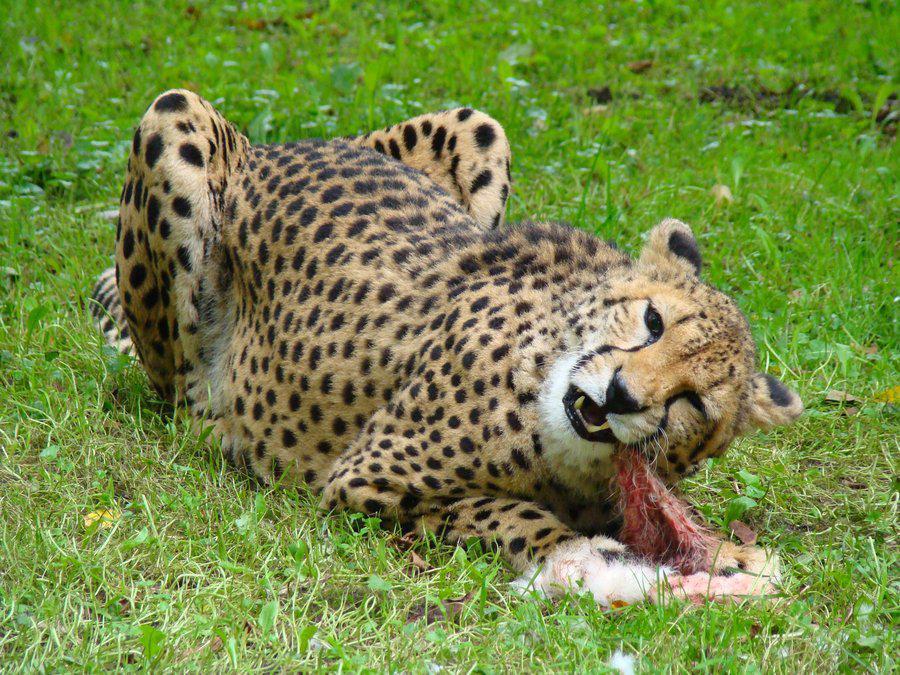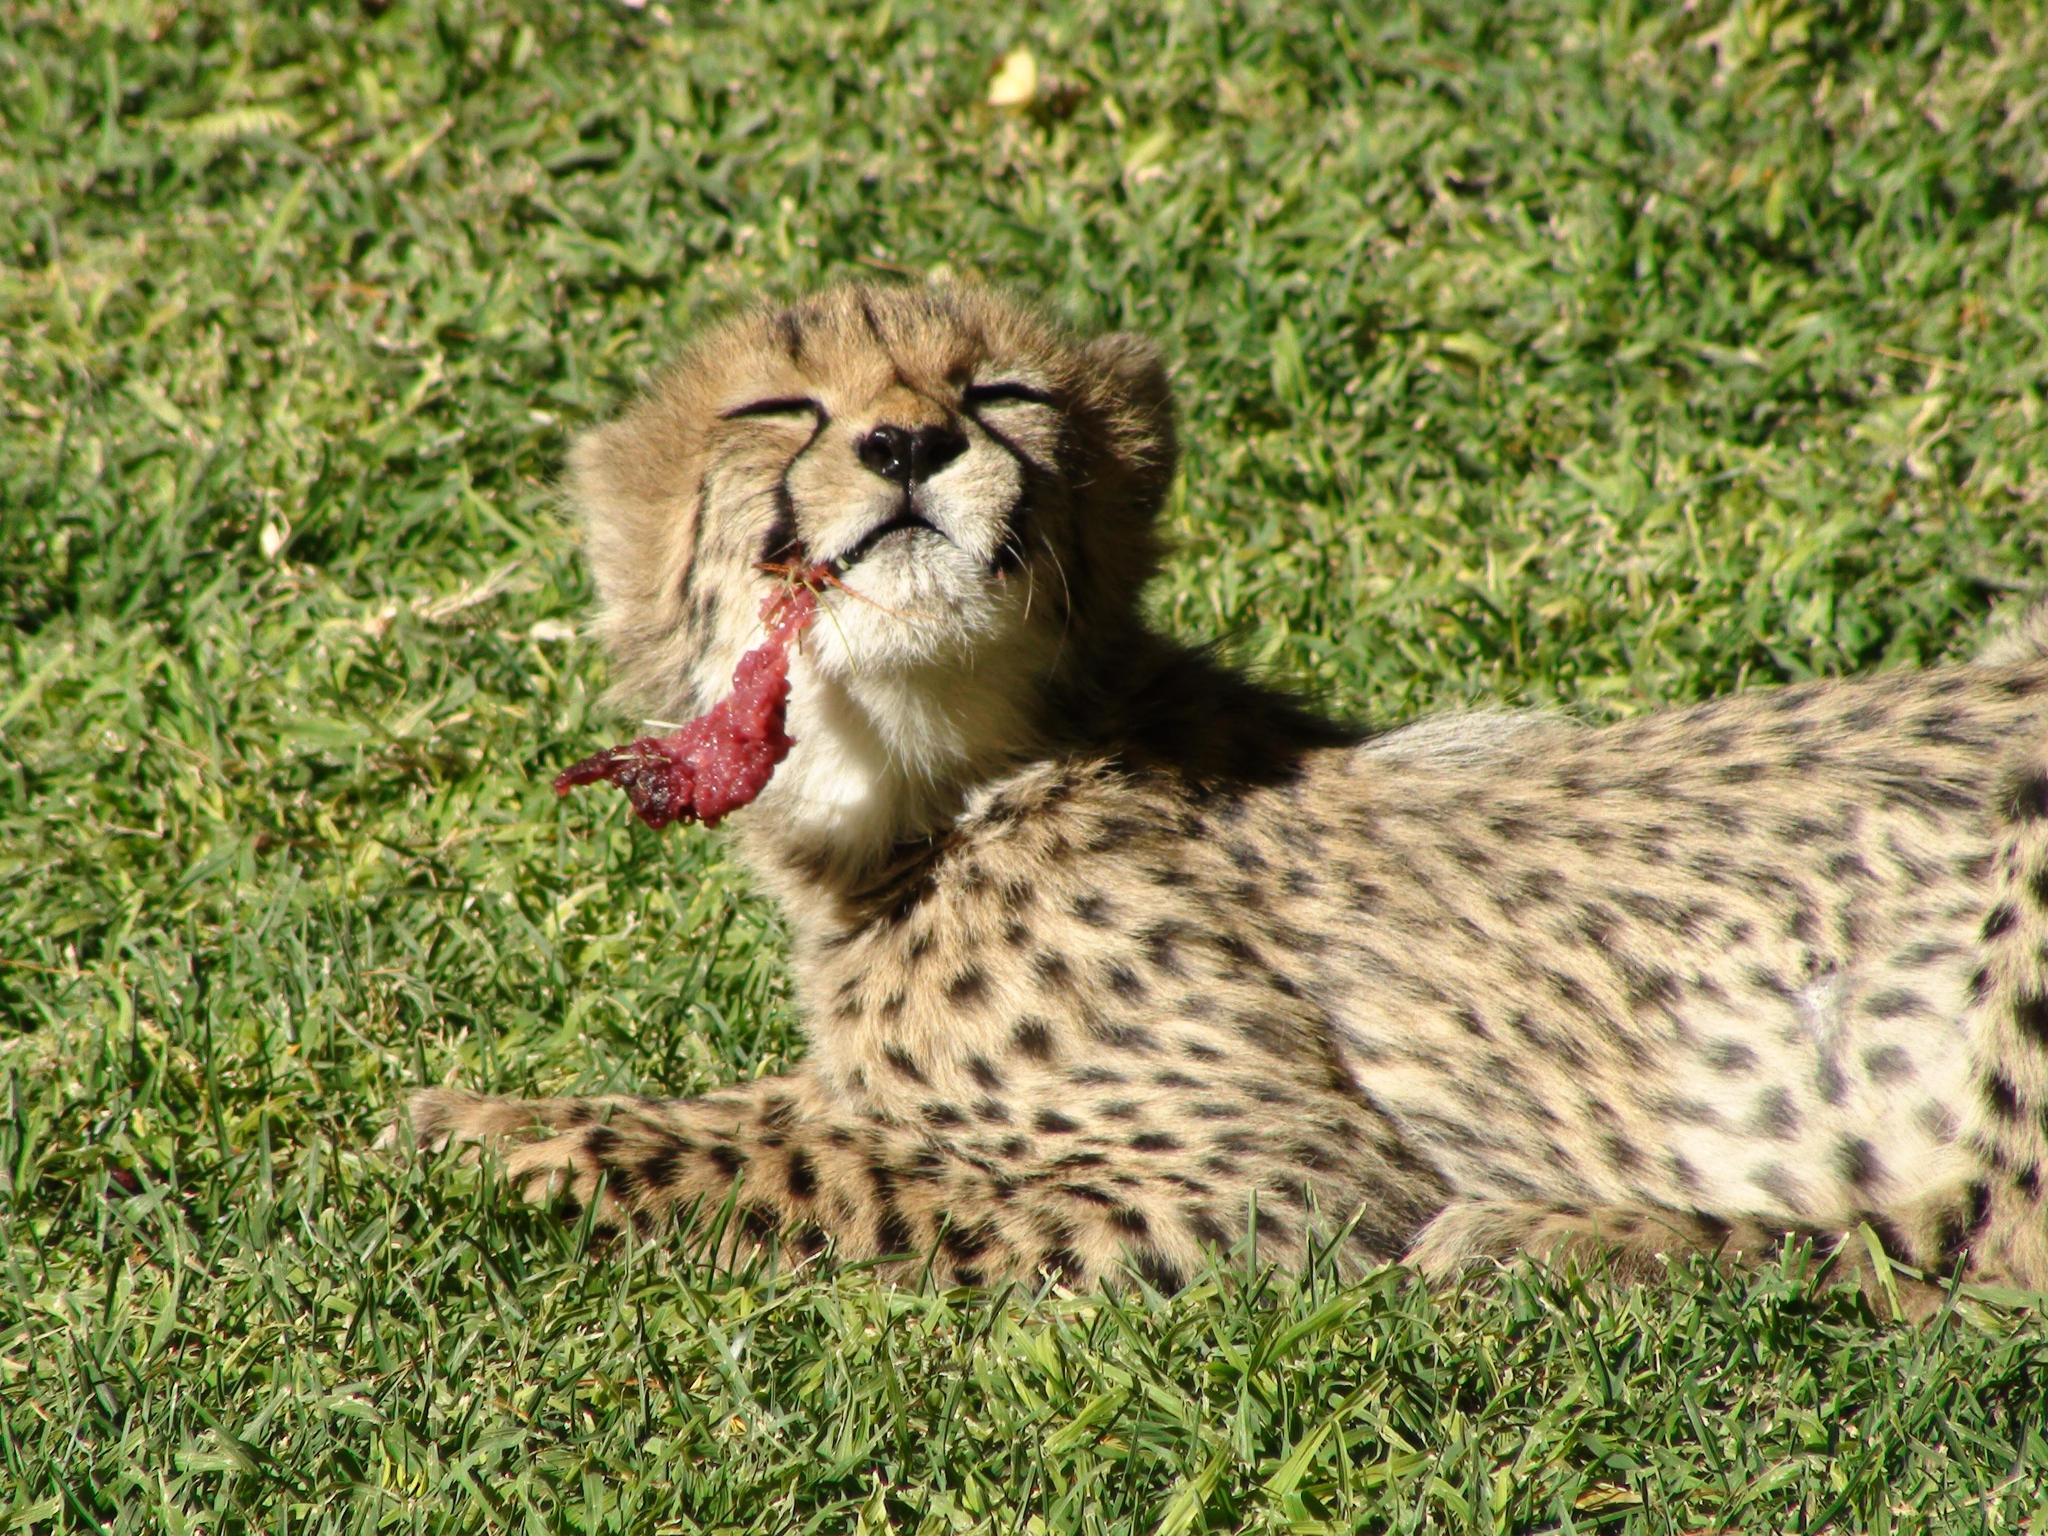The first image is the image on the left, the second image is the image on the right. Considering the images on both sides, is "One cheetah's teeth are visible." valid? Answer yes or no. Yes. The first image is the image on the left, the second image is the image on the right. Analyze the images presented: Is the assertion "The left image shows a forward angled adult cheetah on the grass on its haunches with a piece of red flesh in front of it." valid? Answer yes or no. Yes. 